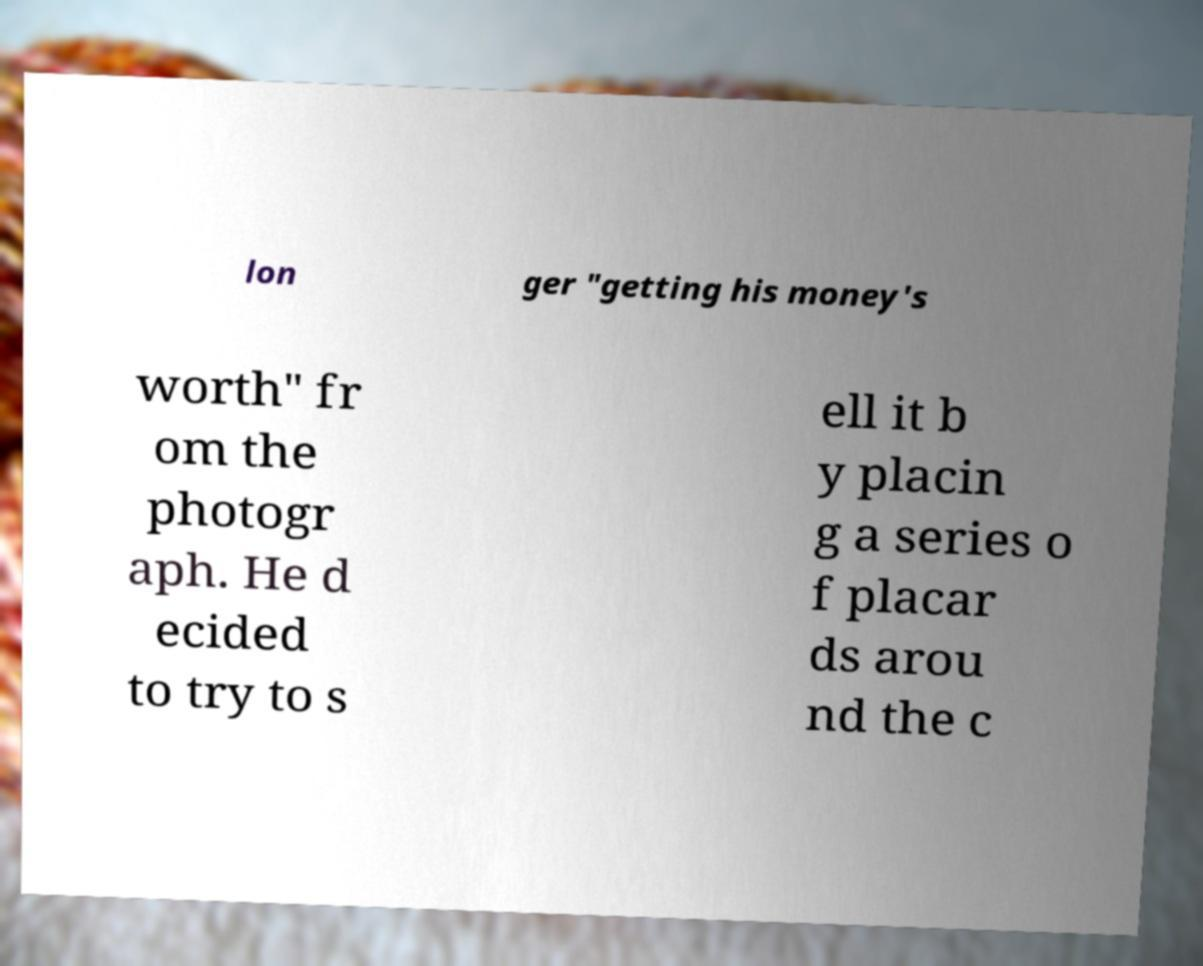Please read and relay the text visible in this image. What does it say? lon ger "getting his money's worth" fr om the photogr aph. He d ecided to try to s ell it b y placin g a series o f placar ds arou nd the c 